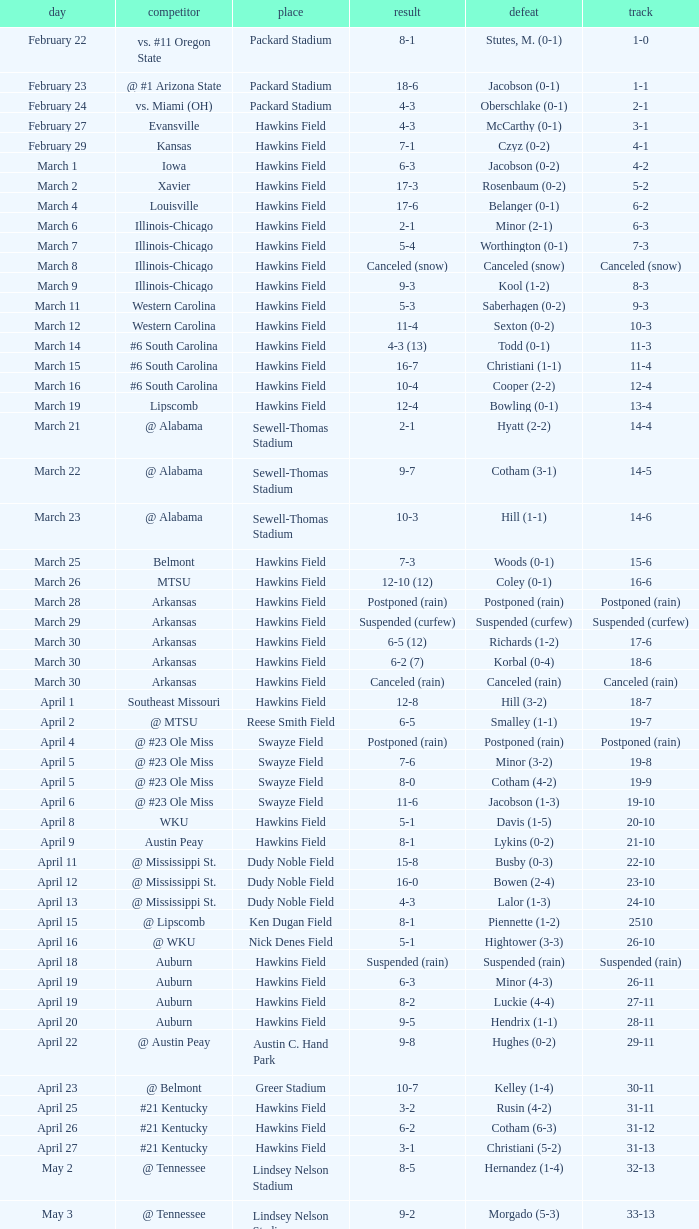Would you mind parsing the complete table? {'header': ['day', 'competitor', 'place', 'result', 'defeat', 'track'], 'rows': [['February 22', 'vs. #11 Oregon State', 'Packard Stadium', '8-1', 'Stutes, M. (0-1)', '1-0'], ['February 23', '@ #1 Arizona State', 'Packard Stadium', '18-6', 'Jacobson (0-1)', '1-1'], ['February 24', 'vs. Miami (OH)', 'Packard Stadium', '4-3', 'Oberschlake (0-1)', '2-1'], ['February 27', 'Evansville', 'Hawkins Field', '4-3', 'McCarthy (0-1)', '3-1'], ['February 29', 'Kansas', 'Hawkins Field', '7-1', 'Czyz (0-2)', '4-1'], ['March 1', 'Iowa', 'Hawkins Field', '6-3', 'Jacobson (0-2)', '4-2'], ['March 2', 'Xavier', 'Hawkins Field', '17-3', 'Rosenbaum (0-2)', '5-2'], ['March 4', 'Louisville', 'Hawkins Field', '17-6', 'Belanger (0-1)', '6-2'], ['March 6', 'Illinois-Chicago', 'Hawkins Field', '2-1', 'Minor (2-1)', '6-3'], ['March 7', 'Illinois-Chicago', 'Hawkins Field', '5-4', 'Worthington (0-1)', '7-3'], ['March 8', 'Illinois-Chicago', 'Hawkins Field', 'Canceled (snow)', 'Canceled (snow)', 'Canceled (snow)'], ['March 9', 'Illinois-Chicago', 'Hawkins Field', '9-3', 'Kool (1-2)', '8-3'], ['March 11', 'Western Carolina', 'Hawkins Field', '5-3', 'Saberhagen (0-2)', '9-3'], ['March 12', 'Western Carolina', 'Hawkins Field', '11-4', 'Sexton (0-2)', '10-3'], ['March 14', '#6 South Carolina', 'Hawkins Field', '4-3 (13)', 'Todd (0-1)', '11-3'], ['March 15', '#6 South Carolina', 'Hawkins Field', '16-7', 'Christiani (1-1)', '11-4'], ['March 16', '#6 South Carolina', 'Hawkins Field', '10-4', 'Cooper (2-2)', '12-4'], ['March 19', 'Lipscomb', 'Hawkins Field', '12-4', 'Bowling (0-1)', '13-4'], ['March 21', '@ Alabama', 'Sewell-Thomas Stadium', '2-1', 'Hyatt (2-2)', '14-4'], ['March 22', '@ Alabama', 'Sewell-Thomas Stadium', '9-7', 'Cotham (3-1)', '14-5'], ['March 23', '@ Alabama', 'Sewell-Thomas Stadium', '10-3', 'Hill (1-1)', '14-6'], ['March 25', 'Belmont', 'Hawkins Field', '7-3', 'Woods (0-1)', '15-6'], ['March 26', 'MTSU', 'Hawkins Field', '12-10 (12)', 'Coley (0-1)', '16-6'], ['March 28', 'Arkansas', 'Hawkins Field', 'Postponed (rain)', 'Postponed (rain)', 'Postponed (rain)'], ['March 29', 'Arkansas', 'Hawkins Field', 'Suspended (curfew)', 'Suspended (curfew)', 'Suspended (curfew)'], ['March 30', 'Arkansas', 'Hawkins Field', '6-5 (12)', 'Richards (1-2)', '17-6'], ['March 30', 'Arkansas', 'Hawkins Field', '6-2 (7)', 'Korbal (0-4)', '18-6'], ['March 30', 'Arkansas', 'Hawkins Field', 'Canceled (rain)', 'Canceled (rain)', 'Canceled (rain)'], ['April 1', 'Southeast Missouri', 'Hawkins Field', '12-8', 'Hill (3-2)', '18-7'], ['April 2', '@ MTSU', 'Reese Smith Field', '6-5', 'Smalley (1-1)', '19-7'], ['April 4', '@ #23 Ole Miss', 'Swayze Field', 'Postponed (rain)', 'Postponed (rain)', 'Postponed (rain)'], ['April 5', '@ #23 Ole Miss', 'Swayze Field', '7-6', 'Minor (3-2)', '19-8'], ['April 5', '@ #23 Ole Miss', 'Swayze Field', '8-0', 'Cotham (4-2)', '19-9'], ['April 6', '@ #23 Ole Miss', 'Swayze Field', '11-6', 'Jacobson (1-3)', '19-10'], ['April 8', 'WKU', 'Hawkins Field', '5-1', 'Davis (1-5)', '20-10'], ['April 9', 'Austin Peay', 'Hawkins Field', '8-1', 'Lykins (0-2)', '21-10'], ['April 11', '@ Mississippi St.', 'Dudy Noble Field', '15-8', 'Busby (0-3)', '22-10'], ['April 12', '@ Mississippi St.', 'Dudy Noble Field', '16-0', 'Bowen (2-4)', '23-10'], ['April 13', '@ Mississippi St.', 'Dudy Noble Field', '4-3', 'Lalor (1-3)', '24-10'], ['April 15', '@ Lipscomb', 'Ken Dugan Field', '8-1', 'Piennette (1-2)', '2510'], ['April 16', '@ WKU', 'Nick Denes Field', '5-1', 'Hightower (3-3)', '26-10'], ['April 18', 'Auburn', 'Hawkins Field', 'Suspended (rain)', 'Suspended (rain)', 'Suspended (rain)'], ['April 19', 'Auburn', 'Hawkins Field', '6-3', 'Minor (4-3)', '26-11'], ['April 19', 'Auburn', 'Hawkins Field', '8-2', 'Luckie (4-4)', '27-11'], ['April 20', 'Auburn', 'Hawkins Field', '9-5', 'Hendrix (1-1)', '28-11'], ['April 22', '@ Austin Peay', 'Austin C. Hand Park', '9-8', 'Hughes (0-2)', '29-11'], ['April 23', '@ Belmont', 'Greer Stadium', '10-7', 'Kelley (1-4)', '30-11'], ['April 25', '#21 Kentucky', 'Hawkins Field', '3-2', 'Rusin (4-2)', '31-11'], ['April 26', '#21 Kentucky', 'Hawkins Field', '6-2', 'Cotham (6-3)', '31-12'], ['April 27', '#21 Kentucky', 'Hawkins Field', '3-1', 'Christiani (5-2)', '31-13'], ['May 2', '@ Tennessee', 'Lindsey Nelson Stadium', '8-5', 'Hernandez (1-4)', '32-13'], ['May 3', '@ Tennessee', 'Lindsey Nelson Stadium', '9-2', 'Morgado (5-3)', '33-13'], ['May 4', '@ Tennessee', 'Lindsey Nelson Stadium', '10-8', 'Wiltz (3-2)', '34-13'], ['May 6', 'vs. Memphis', 'Pringles Park', '8-0', 'Martin (4-3)', '35-13'], ['May 7', 'Tennessee Tech', 'Hawkins Field', '7-2', 'Liberatore (1-1)', '36-13'], ['May 9', '#9 Georgia', 'Hawkins Field', '13-7', 'Holder (7-3)', '37-13'], ['May 10', '#9 Georgia', 'Hawkins Field', '4-2 (10)', 'Brewer (4-1)', '37-14'], ['May 11', '#9 Georgia', 'Hawkins Field', '12-10', 'Christiani (5-3)', '37-15'], ['May 15', '@ Florida', 'McKethan Stadium', '8-6', 'Brewer (4-2)', '37-16'], ['May 16', '@ Florida', 'McKethan Stadium', '5-4', 'Cotham (7-4)', '37-17'], ['May 17', '@ Florida', 'McKethan Stadium', '13-12 (11)', 'Jacobson (1-4)', '37-18']]} What was the location of the game when the record was 12-4? Hawkins Field. 